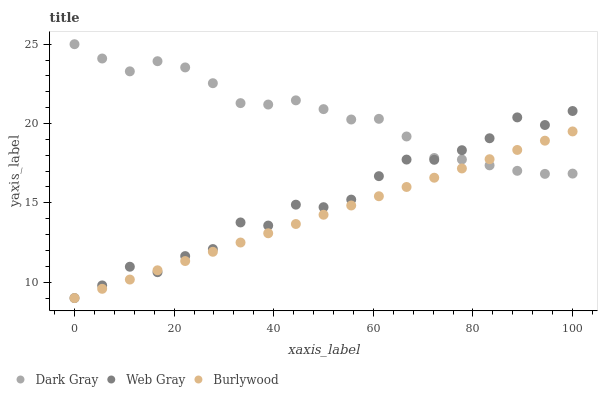Does Burlywood have the minimum area under the curve?
Answer yes or no. Yes. Does Dark Gray have the maximum area under the curve?
Answer yes or no. Yes. Does Web Gray have the minimum area under the curve?
Answer yes or no. No. Does Web Gray have the maximum area under the curve?
Answer yes or no. No. Is Burlywood the smoothest?
Answer yes or no. Yes. Is Web Gray the roughest?
Answer yes or no. Yes. Is Web Gray the smoothest?
Answer yes or no. No. Is Burlywood the roughest?
Answer yes or no. No. Does Burlywood have the lowest value?
Answer yes or no. Yes. Does Dark Gray have the highest value?
Answer yes or no. Yes. Does Web Gray have the highest value?
Answer yes or no. No. Does Dark Gray intersect Burlywood?
Answer yes or no. Yes. Is Dark Gray less than Burlywood?
Answer yes or no. No. Is Dark Gray greater than Burlywood?
Answer yes or no. No. 